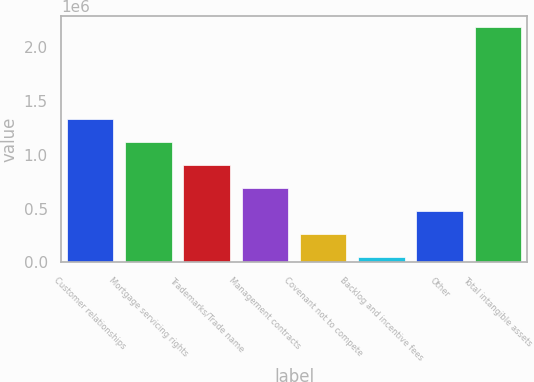Convert chart. <chart><loc_0><loc_0><loc_500><loc_500><bar_chart><fcel>Customer relationships<fcel>Mortgage servicing rights<fcel>Trademarks/Trade name<fcel>Management contracts<fcel>Covenant not to compete<fcel>Backlog and incentive fees<fcel>Other<fcel>Total intangible assets<nl><fcel>1.32901e+06<fcel>1.11558e+06<fcel>902152<fcel>688725<fcel>261872<fcel>48445<fcel>475298<fcel>2.18271e+06<nl></chart> 